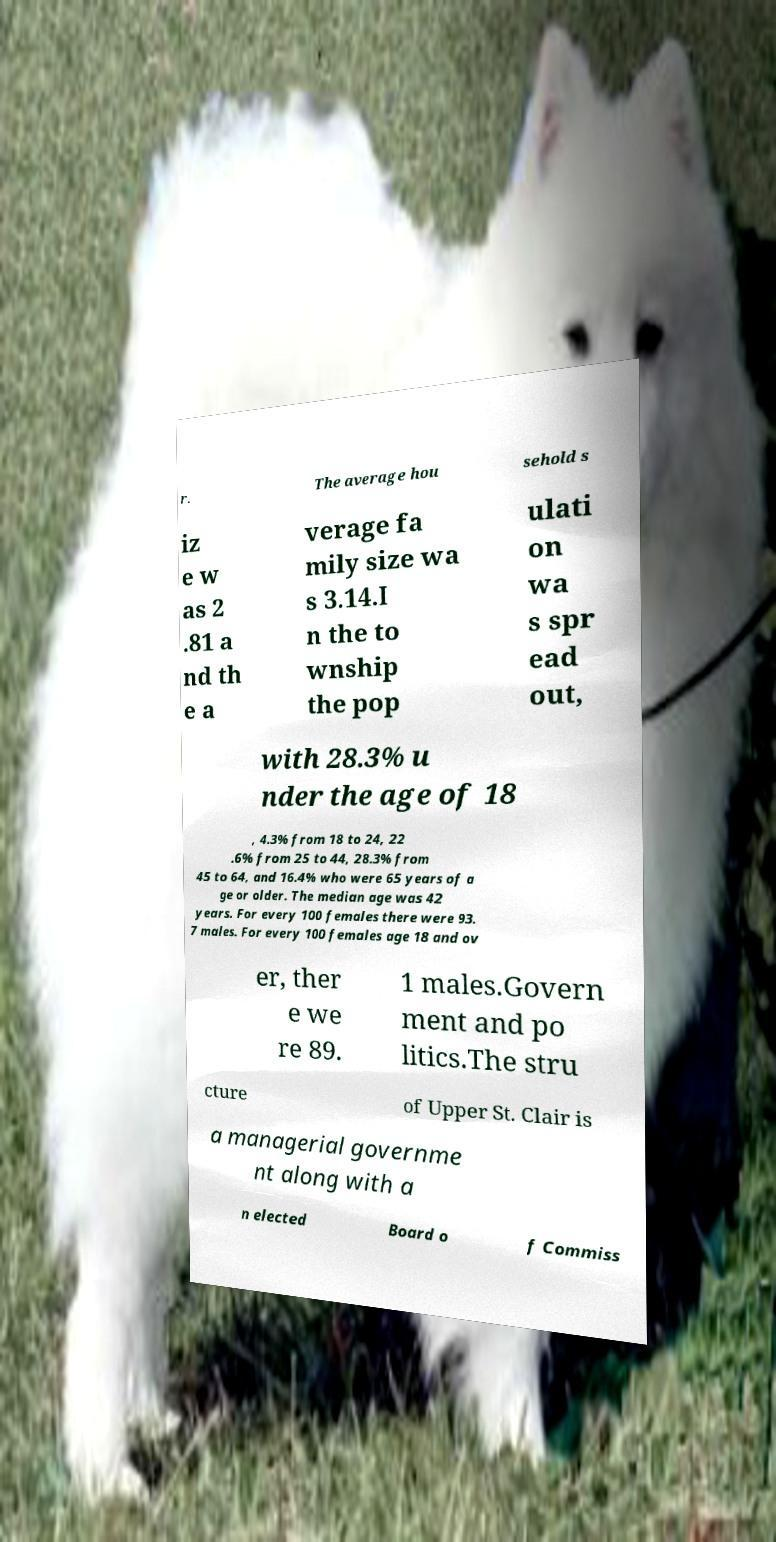For documentation purposes, I need the text within this image transcribed. Could you provide that? r. The average hou sehold s iz e w as 2 .81 a nd th e a verage fa mily size wa s 3.14.I n the to wnship the pop ulati on wa s spr ead out, with 28.3% u nder the age of 18 , 4.3% from 18 to 24, 22 .6% from 25 to 44, 28.3% from 45 to 64, and 16.4% who were 65 years of a ge or older. The median age was 42 years. For every 100 females there were 93. 7 males. For every 100 females age 18 and ov er, ther e we re 89. 1 males.Govern ment and po litics.The stru cture of Upper St. Clair is a managerial governme nt along with a n elected Board o f Commiss 